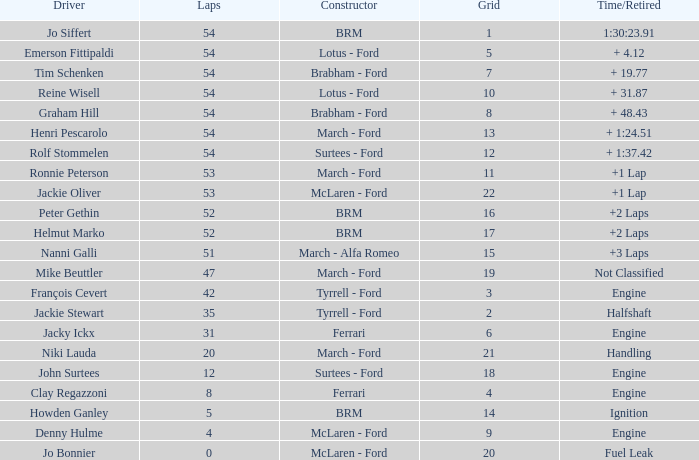What is the low grid that has brm and over 54 laps? None. 